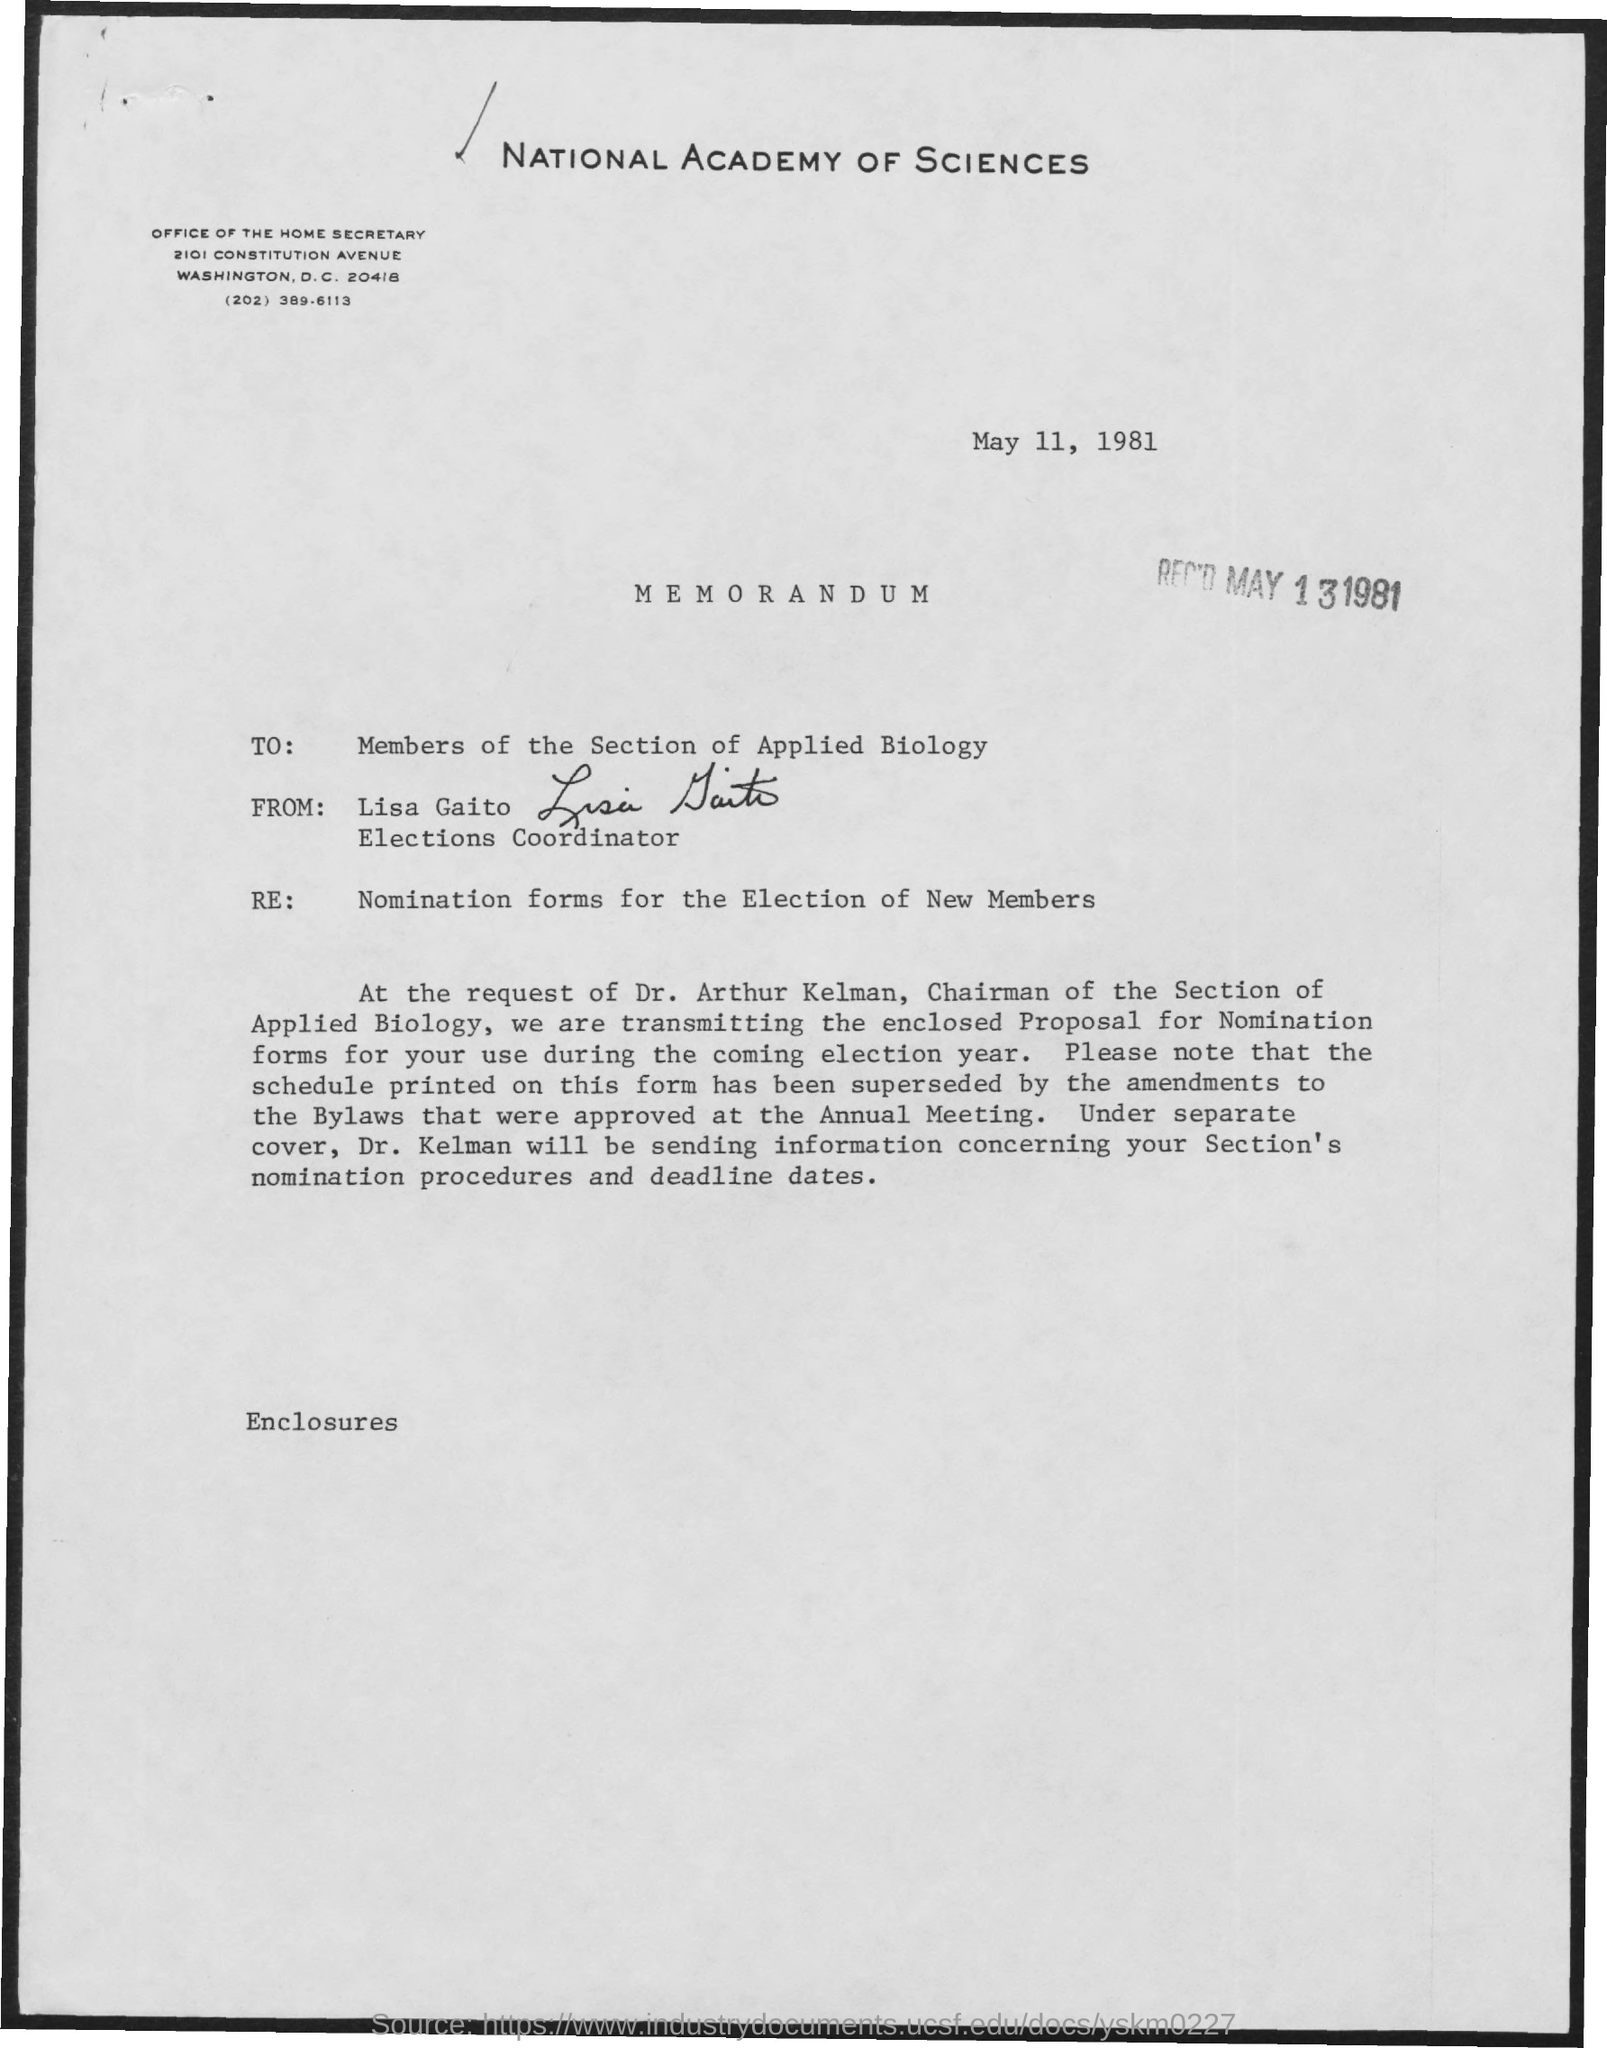What is the date of the letter written
Ensure brevity in your answer.  May 11, 1981. What is the date of received ?
Provide a succinct answer. May 13 1981. To whom this is written
Give a very brief answer. Members of the section of applied biology. From whom this letter is written
Your answer should be very brief. Lisa Gaito. Who is the chairman of the section of applied biology
Provide a succinct answer. Dr. Arthur Kelman. Who is the election coordinator
Your response must be concise. Lisa Gaito. 